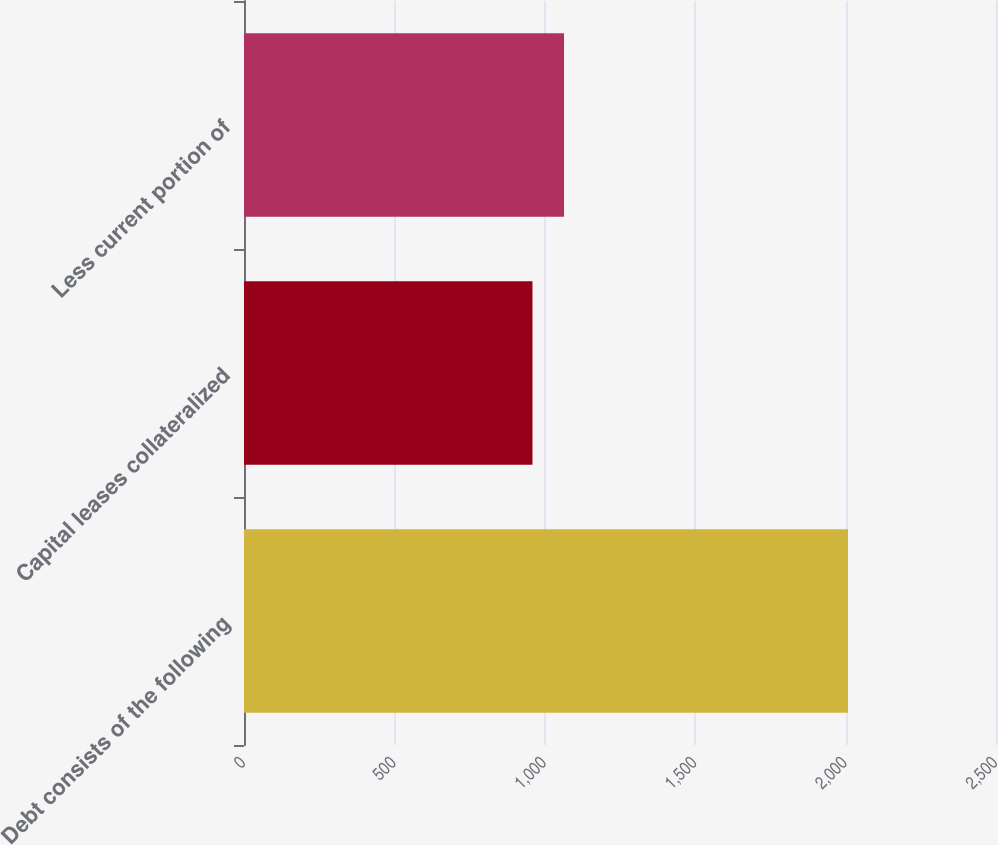Convert chart to OTSL. <chart><loc_0><loc_0><loc_500><loc_500><bar_chart><fcel>Debt consists of the following<fcel>Capital leases collateralized<fcel>Less current portion of<nl><fcel>2008<fcel>959<fcel>1063.9<nl></chart> 